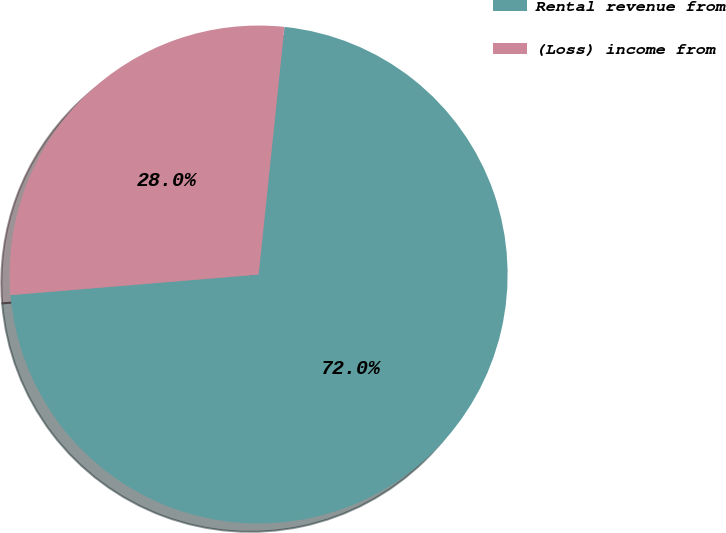Convert chart to OTSL. <chart><loc_0><loc_0><loc_500><loc_500><pie_chart><fcel>Rental revenue from<fcel>(Loss) income from<nl><fcel>72.03%<fcel>27.97%<nl></chart> 